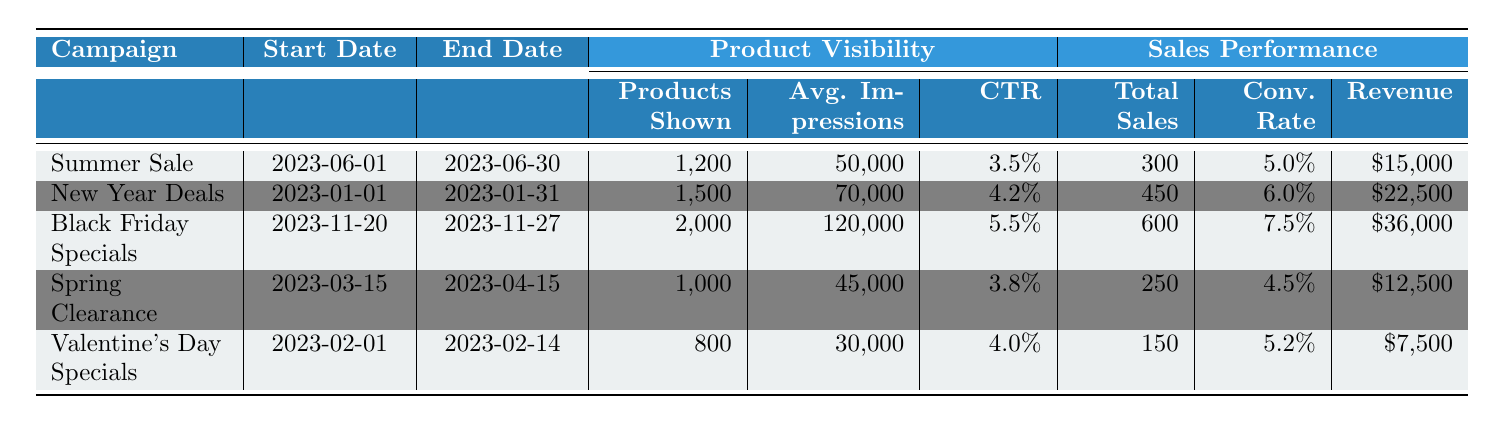What is the total revenue generated by the "Black Friday Specials" campaign? The revenue for the "Black Friday Specials" campaign is listed under the Sales Performance section as "$36,000."
Answer: $36,000 What was the average click-through rate (CTR) across all campaigns? The click-through rates are given as 3.5%, 4.2%, 5.5%, 3.8%, and 4.0%, which sum to 20%. Dividing by the number of campaigns (5) gives an average of 20% / 5 = 4.0%.
Answer: 4.0% How many products were shown during the "New Year Deals" campaign? According to the table, the number of products shown for "New Year Deals" is listed as 1,500.
Answer: 1,500 Which campaign had the highest total sales? The total sales figures for each campaign are 300 (Summer Sale), 450 (New Year Deals), 600 (Black Friday Specials), 250 (Spring Clearance), and 150 (Valentine's Day Specials). The highest figure is 600 from the "Black Friday Specials."
Answer: Black Friday Specials Did the "Valentine's Day Specials" campaign have a higher conversion rate than the "Spring Clearance" campaign? The conversion rates are 5.2% for "Valentine's Day Specials" and 4.5% for "Spring Clearance." Since 5.2% is greater than 4.5%, the statement is true.
Answer: Yes What is the difference in average impressions between the "Black Friday Specials" and "Summer Sale" campaigns? "Black Friday Specials" has average impressions of 120,000 and "Summer Sale" has 50,000. The difference is 120,000 - 50,000 = 70,000.
Answer: 70,000 What percentage of the products shown in the "Spring Clearance" campaign converted into sales? The "Spring Clearance" campaign showed 1,000 products and had total sales of 250. The conversion percentage is (250 / 1000) * 100 = 25%.
Answer: 25% Which campaign had the lowest average impressions? The average impressions for each campaign are 50,000 (Summer Sale), 70,000 (New Year Deals), 120,000 (Black Friday Specials), 45,000 (Spring Clearance), and 30,000 (Valentine's Day Specials). The lowest is 30,000 from the "Valentine's Day Specials."
Answer: Valentine's Day Specials If we total the revenue from all campaigns, what is the overall revenue? The revenues are "$15,000" (Summer Sale), "$22,500" (New Year Deals), "$36,000" (Black Friday Specials), "$12,500" (Spring Clearance), and "$7,500" (Valentine's Day Specials). Adding them gives $15,000 + $22,500 + $36,000 + $12,500 + $7,500 = $93,500.
Answer: $93,500 Which campaign ran the longest duration? The durations are evaluated as follows: "Summer Sale" (30 days), "New Year Deals" (31 days), "Black Friday Specials" (7 days), "Spring Clearance" (31 days), and "Valentine's Day Specials" (14 days). The longest duration is 31 days, which applies to both "New Year Deals" and "Spring Clearance."
Answer: New Year Deals, Spring Clearance 